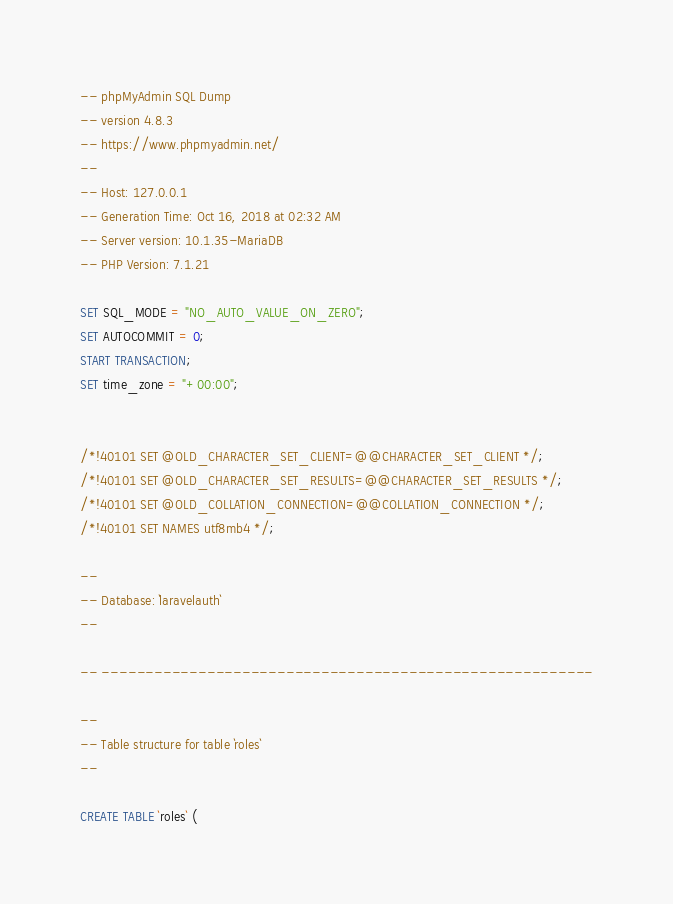<code> <loc_0><loc_0><loc_500><loc_500><_SQL_>-- phpMyAdmin SQL Dump
-- version 4.8.3
-- https://www.phpmyadmin.net/
--
-- Host: 127.0.0.1
-- Generation Time: Oct 16, 2018 at 02:32 AM
-- Server version: 10.1.35-MariaDB
-- PHP Version: 7.1.21

SET SQL_MODE = "NO_AUTO_VALUE_ON_ZERO";
SET AUTOCOMMIT = 0;
START TRANSACTION;
SET time_zone = "+00:00";


/*!40101 SET @OLD_CHARACTER_SET_CLIENT=@@CHARACTER_SET_CLIENT */;
/*!40101 SET @OLD_CHARACTER_SET_RESULTS=@@CHARACTER_SET_RESULTS */;
/*!40101 SET @OLD_COLLATION_CONNECTION=@@COLLATION_CONNECTION */;
/*!40101 SET NAMES utf8mb4 */;

--
-- Database: `laravelauth`
--

-- --------------------------------------------------------

--
-- Table structure for table `roles`
--

CREATE TABLE `roles` (</code> 